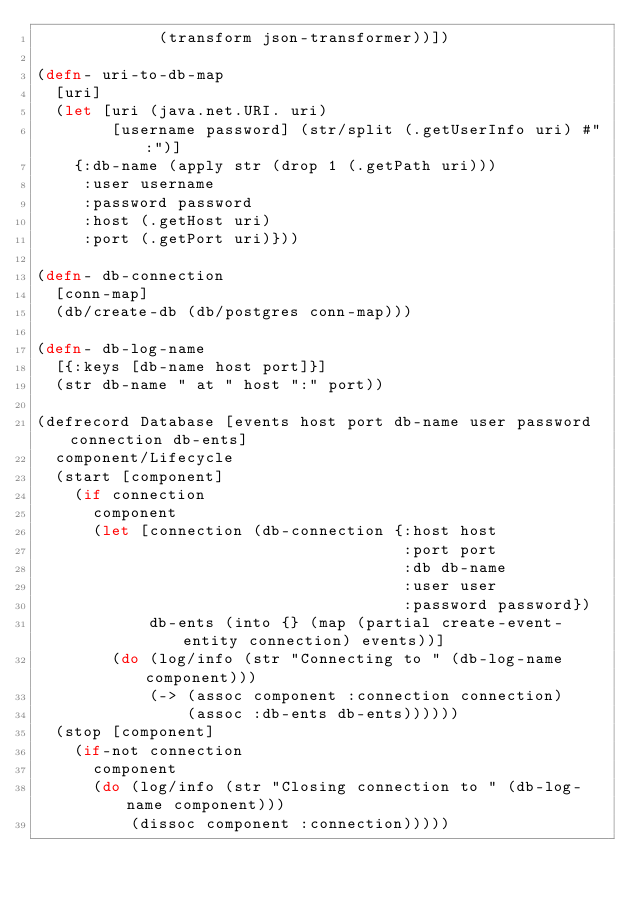<code> <loc_0><loc_0><loc_500><loc_500><_Clojure_>             (transform json-transformer))])

(defn- uri-to-db-map
  [uri]
  (let [uri (java.net.URI. uri)
        [username password] (str/split (.getUserInfo uri) #":")]
    {:db-name (apply str (drop 1 (.getPath uri)))
     :user username
     :password password
     :host (.getHost uri)
     :port (.getPort uri)}))

(defn- db-connection
  [conn-map]
  (db/create-db (db/postgres conn-map)))

(defn- db-log-name 
  [{:keys [db-name host port]}]
  (str db-name " at " host ":" port))

(defrecord Database [events host port db-name user password connection db-ents]
  component/Lifecycle
  (start [component]
    (if connection 
      component 
      (let [connection (db-connection {:host host
                                       :port port
                                       :db db-name
                                       :user user
                                       :password password})
            db-ents (into {} (map (partial create-event-entity connection) events))]
        (do (log/info (str "Connecting to " (db-log-name component)))
            (-> (assoc component :connection connection)
                (assoc :db-ents db-ents))))))
  (stop [component]
    (if-not connection
      component
      (do (log/info (str "Closing connection to " (db-log-name component)))
          (dissoc component :connection)))))
</code> 